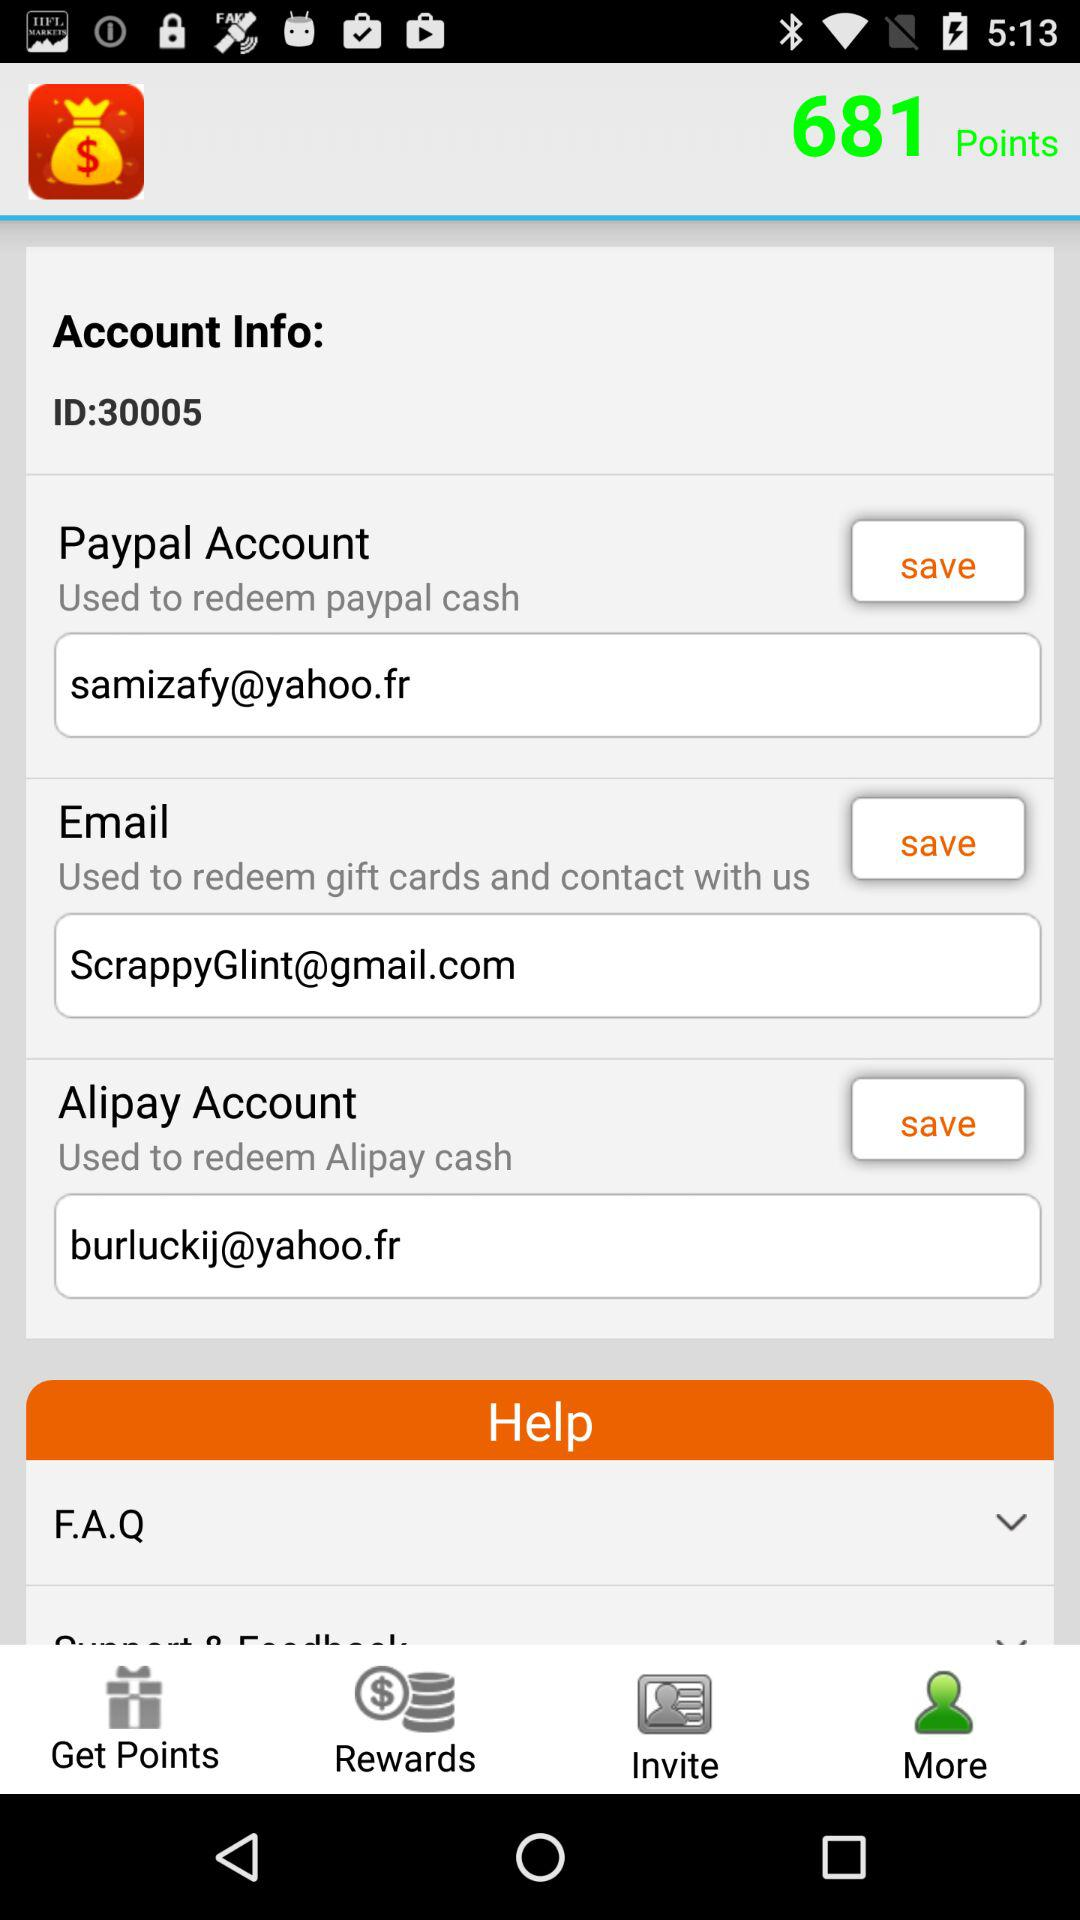What is the email address associated with the Paypal account? The email address is samizafy@yahoo.fr. 